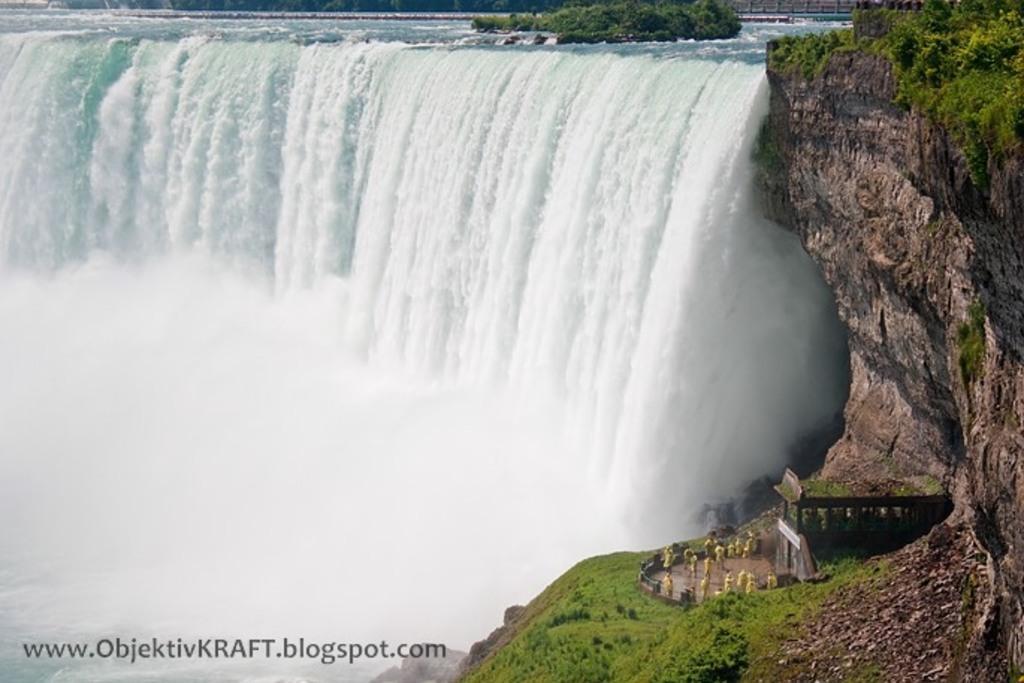Could you give a brief overview of what you see in this image? In this image there is a waterfall. To the right there are rocky mountains. There are plants on the mountains. There is a house on the mountains. In front of the house there are a few people standing. In the bottom left there is text on the image. At the top there are trees on the water. 